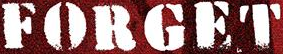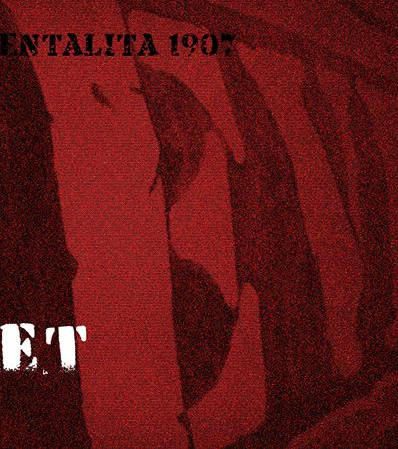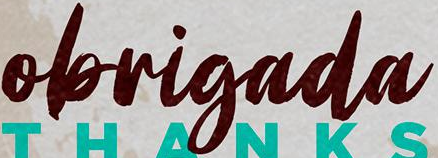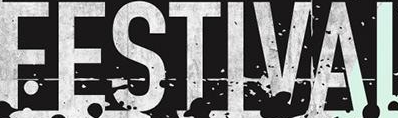What words are shown in these images in order, separated by a semicolon? FORGET; EV; obrigada; FESTIVAI 